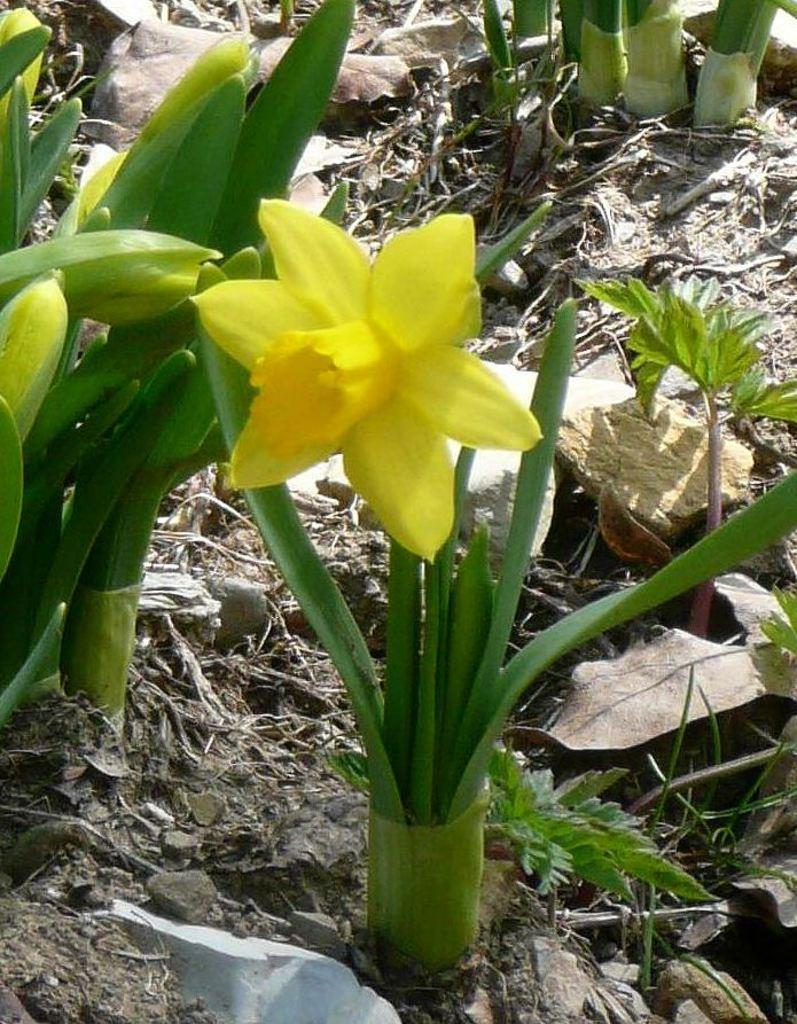What type of plants can be seen on the ground in the image? There are many flower plants on the ground in the image. Can you describe a specific flower in the image? Yes, there is a yellow flower in the image. What else can be found on the ground in the image? Dried leaves are present on the ground in the image. How does the crowd in the image support the experience of the flower plants? There is no crowd present in the image, so it cannot support the experience of the flower plants. 